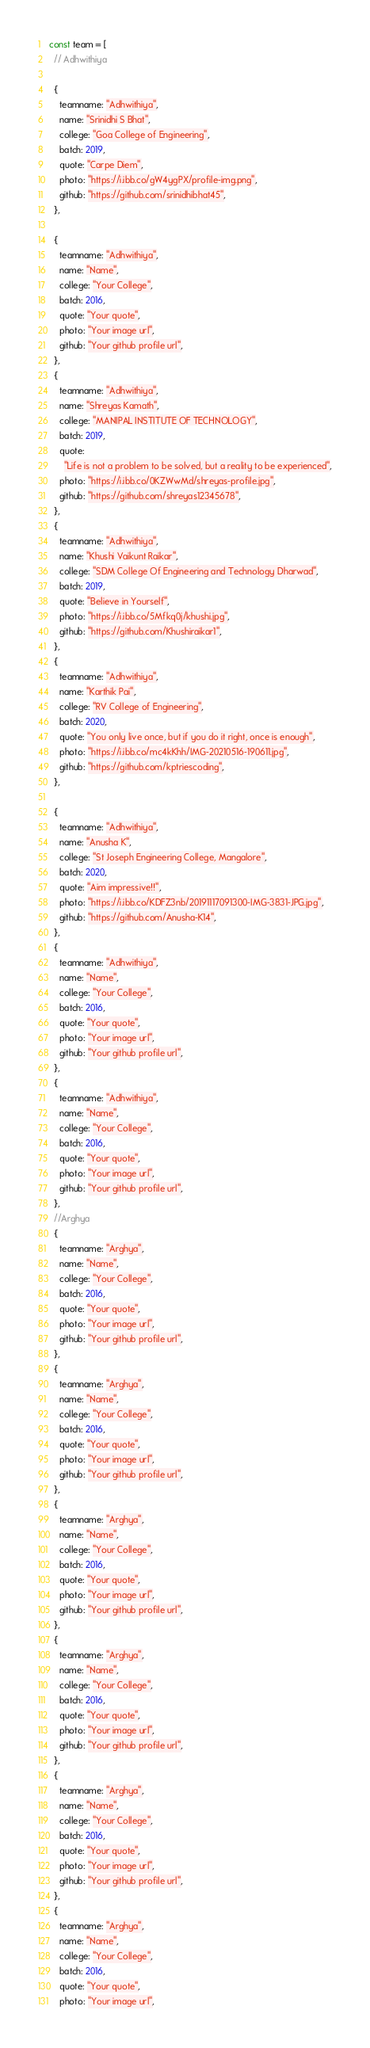Convert code to text. <code><loc_0><loc_0><loc_500><loc_500><_JavaScript_>const team = [
  // Adhwithiya

  {
    teamname: "Adhwithiya",
    name: "Srinidhi S Bhat",
    college: "Goa College of Engineering",
    batch: 2019,
    quote: "Carpe Diem",
    photo: "https://i.ibb.co/gW4ygPX/profile-img.png",
    github: "https://github.com/srinidhibhat45",
  },

  {
    teamname: "Adhwithiya",
    name: "Name",
    college: "Your College",
    batch: 2016,
    quote: "Your quote",
    photo: "Your image url",
    github: "Your github profile url",
  },
  {
    teamname: "Adhwithiya",
    name: "Shreyas Kamath",
    college: "MANIPAL INSTITUTE OF TECHNOLOGY",
    batch: 2019,
    quote:
      "Life is not a problem to be solved, but a reality to be experienced",
    photo: "https://i.ibb.co/0KZWwMd/shreyas-profile.jpg",
    github: "https://github.com/shreyas12345678",
  },
  {
    teamname: "Adhwithiya",
    name: "Khushi Vaikunt Raikar",
    college: "SDM College Of Engineering and Technology Dharwad",
    batch: 2019,
    quote: "Believe in Yourself",
    photo: "https://i.ibb.co/5Mfkq0j/khushi.jpg",
    github: "https://github.com/Khushiraikar1",
  },
  {
    teamname: "Adhwithiya",
    name: "Karthik Pai",
    college: "RV College of Engineering",
    batch: 2020,
    quote: "You only live once, but if you do it right, once is enough",
    photo: "https://i.ibb.co/mc4kKhh/IMG-20210516-190611.jpg",
    github: "https://github.com/kptriescoding",
  },

  {
    teamname: "Adhwithiya",
    name: "Anusha K",
    college: "St Joseph Engineering College, Mangalore",
    batch: 2020,
    quote: "Aim impressive!!",
    photo: "https://i.ibb.co/KDFZ3nb/20191117091300-IMG-3831-JPG.jpg",
    github: "https://github.com/Anusha-K14",
  },
  {
    teamname: "Adhwithiya",
    name: "Name",
    college: "Your College",
    batch: 2016,
    quote: "Your quote",
    photo: "Your image url",
    github: "Your github profile url",
  },
  {
    teamname: "Adhwithiya",
    name: "Name",
    college: "Your College",
    batch: 2016,
    quote: "Your quote",
    photo: "Your image url",
    github: "Your github profile url",
  },
  //Arghya
  {
    teamname: "Arghya",
    name: "Name",
    college: "Your College",
    batch: 2016,
    quote: "Your quote",
    photo: "Your image url",
    github: "Your github profile url",
  },
  {
    teamname: "Arghya",
    name: "Name",
    college: "Your College",
    batch: 2016,
    quote: "Your quote",
    photo: "Your image url",
    github: "Your github profile url",
  },
  {
    teamname: "Arghya",
    name: "Name",
    college: "Your College",
    batch: 2016,
    quote: "Your quote",
    photo: "Your image url",
    github: "Your github profile url",
  },
  {
    teamname: "Arghya",
    name: "Name",
    college: "Your College",
    batch: 2016,
    quote: "Your quote",
    photo: "Your image url",
    github: "Your github profile url",
  },
  {
    teamname: "Arghya",
    name: "Name",
    college: "Your College",
    batch: 2016,
    quote: "Your quote",
    photo: "Your image url",
    github: "Your github profile url",
  },
  {
    teamname: "Arghya",
    name: "Name",
    college: "Your College",
    batch: 2016,
    quote: "Your quote",
    photo: "Your image url",</code> 